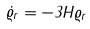<formula> <loc_0><loc_0><loc_500><loc_500>\dot { \varrho } _ { r } = - 3 H \varrho _ { r }</formula> 